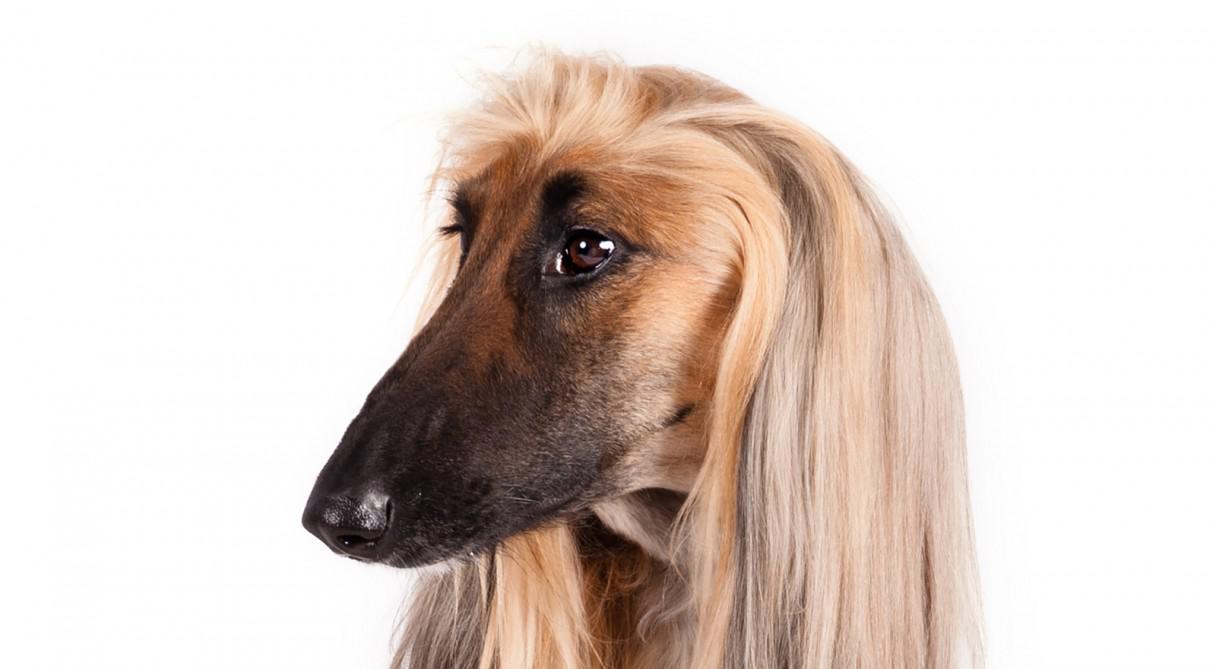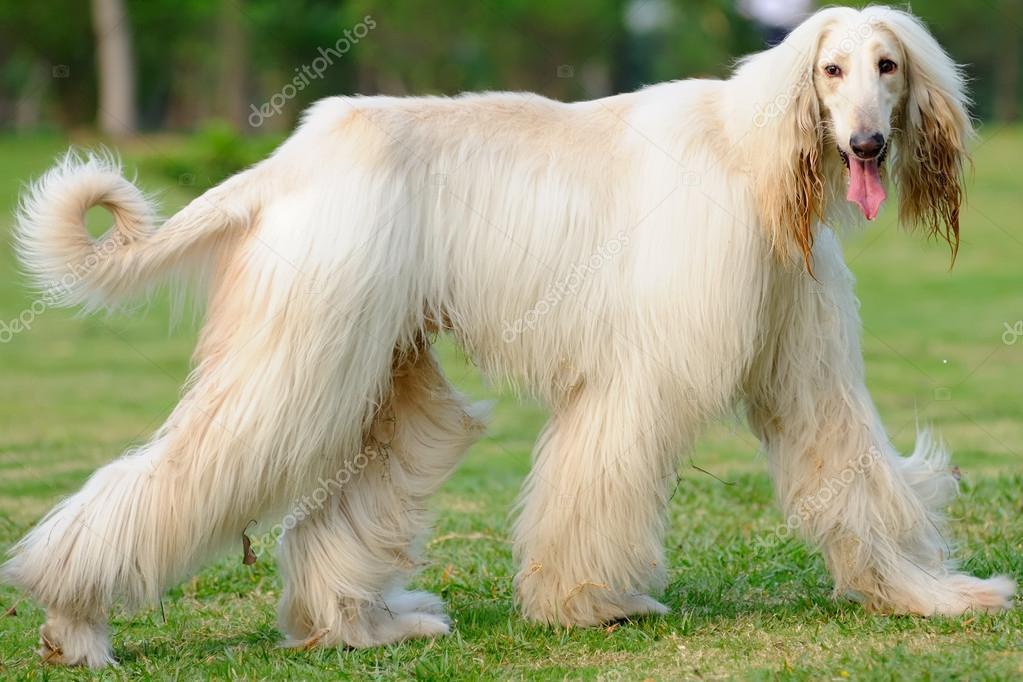The first image is the image on the left, the second image is the image on the right. Assess this claim about the two images: "One image is a standing dog and one is a dog's head.". Correct or not? Answer yes or no. Yes. The first image is the image on the left, the second image is the image on the right. Analyze the images presented: Is the assertion "There is a headshot of a long haired dog." valid? Answer yes or no. Yes. 